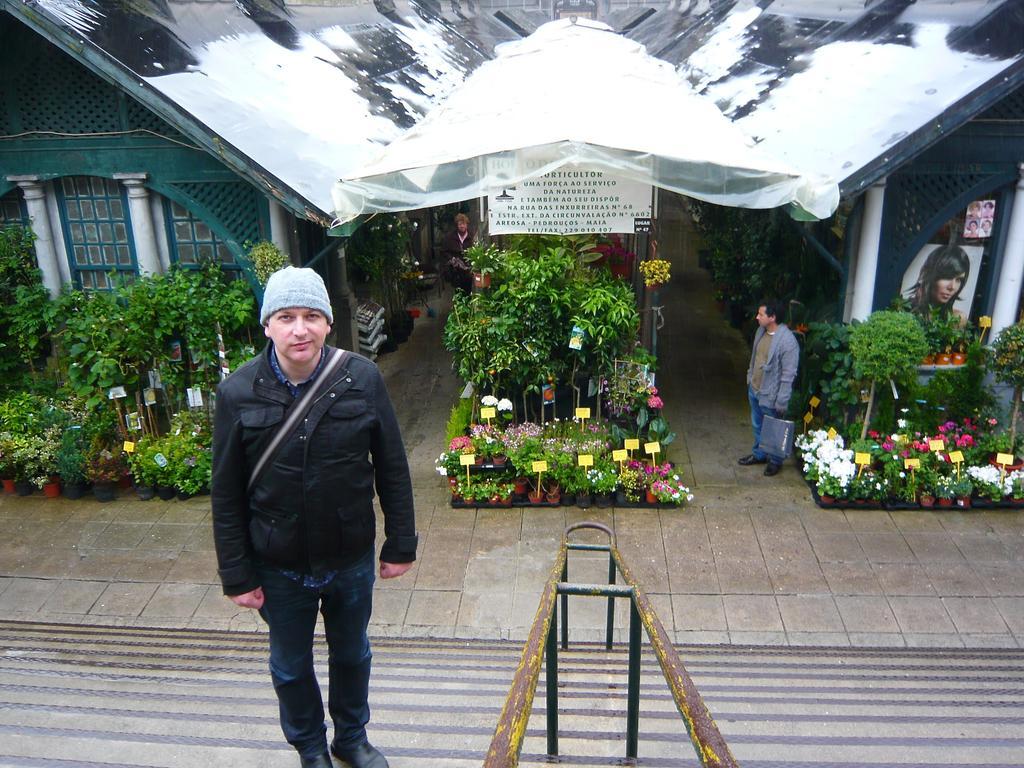In one or two sentences, can you explain what this image depicts? There are two men. Here we can see plants, flowers, and posters. There is a board. In the background we can see houses. 